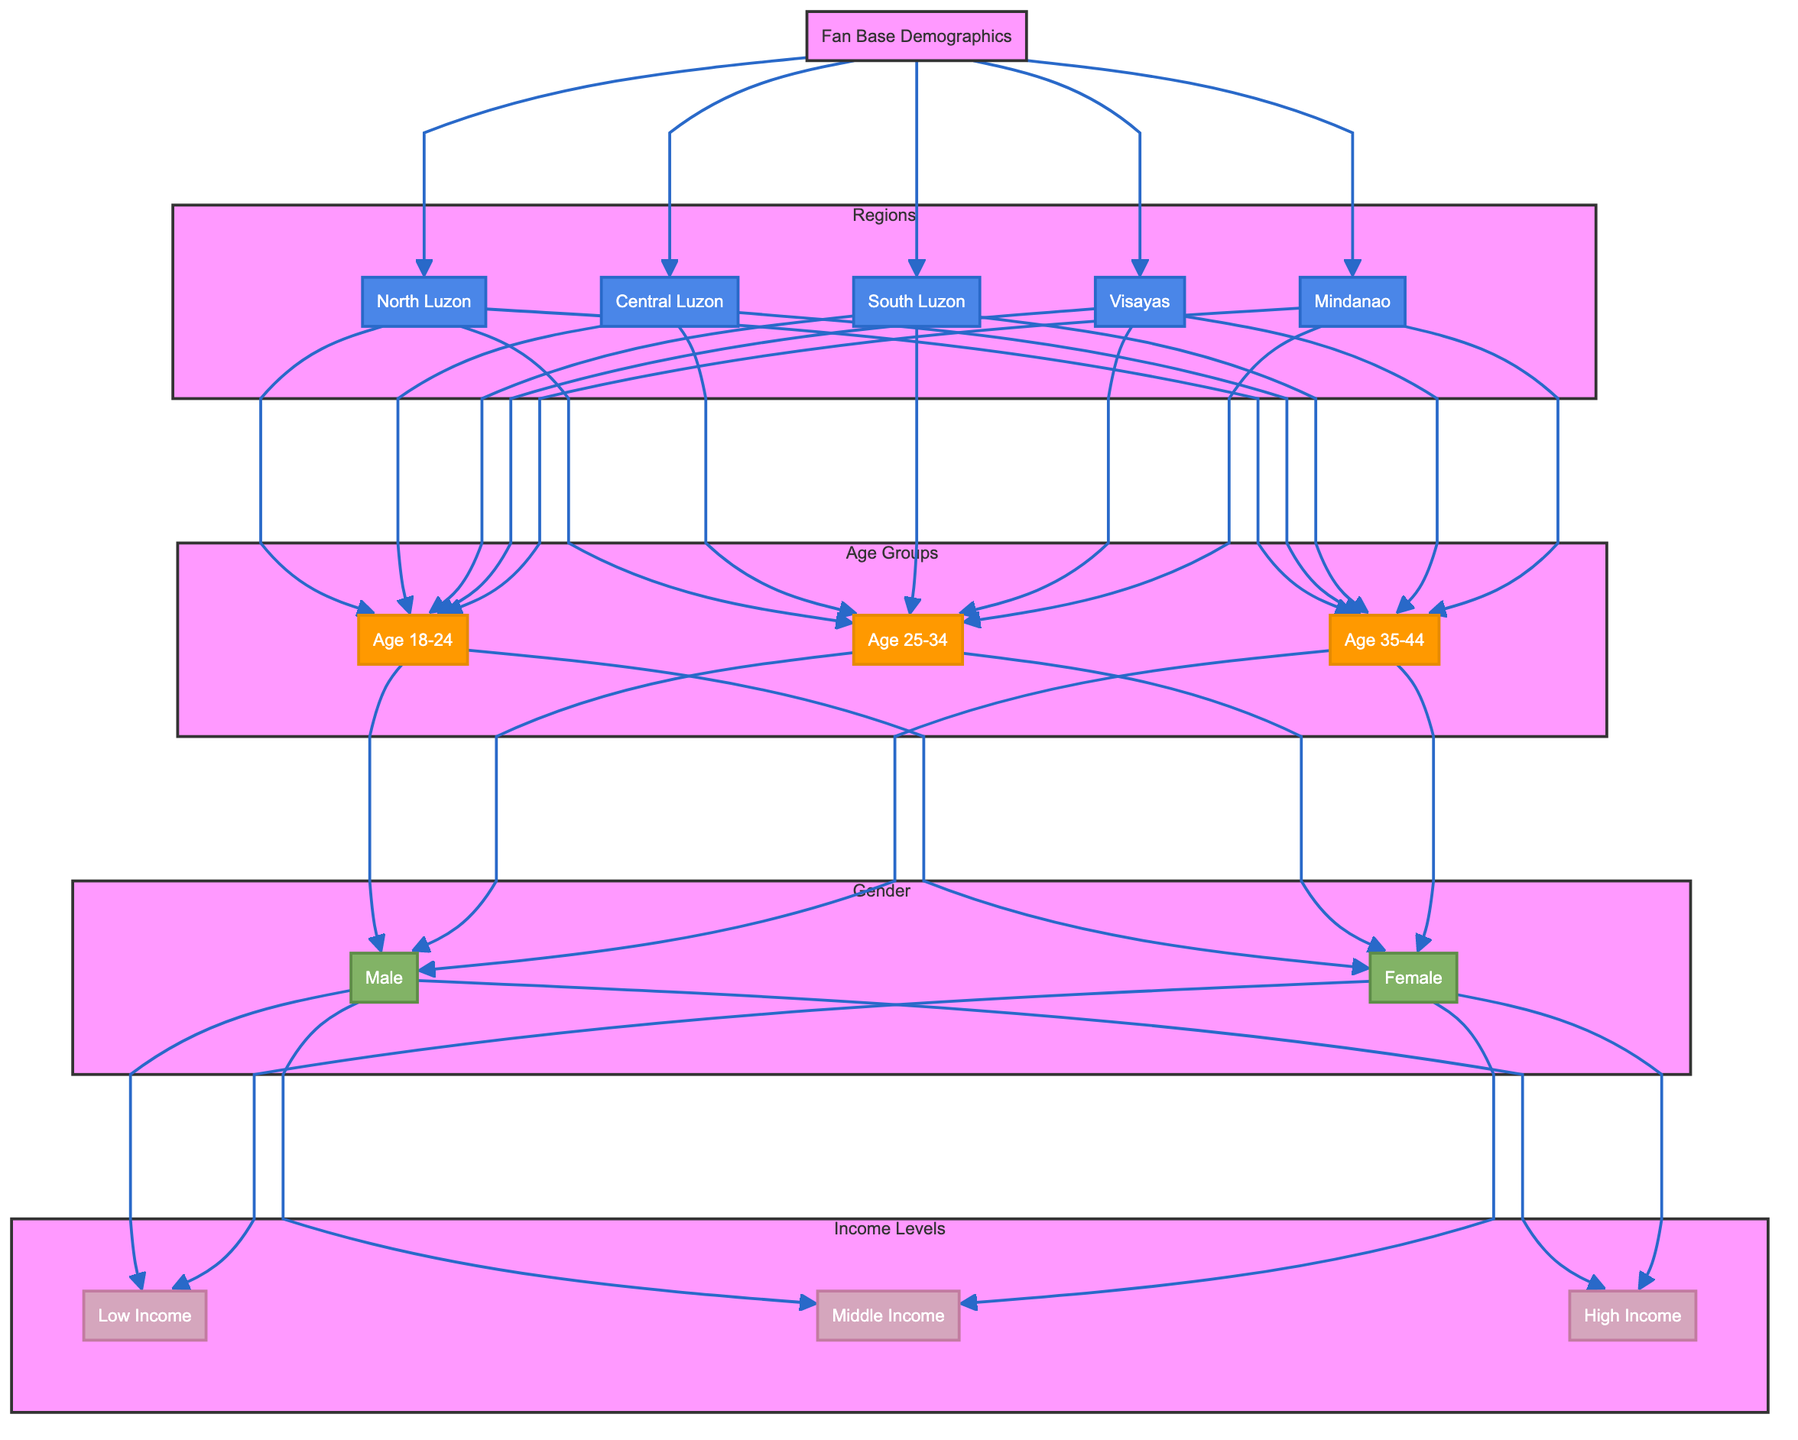What regions are represented in the fan base demographics? The diagram shows five regions: North Luzon, Central Luzon, South Luzon, Visayas, and Mindanao. These are all the sub-nodes directly connected to the root node "Fan Base Demographics."
Answer: North Luzon, Central Luzon, South Luzon, Visayas, Mindanao Which age group is represented first in the flow? The age group that appears first in the flow from the regions is "Age 18-24." This node is directly connected from all the regions as the first age group listed.
Answer: Age 18-24 How many gender categories are included in this diagram? The diagram includes two gender categories, "Male" and "Female," as indicated in the gender subgraph.
Answer: 2 Which income level is connected to the "Female" node? The "Female" node is connected to all three income levels: Low Income, Middle Income, and High Income. This is seen as branches stemming from the Female node in the diagram.
Answer: Low Income, Middle Income, High Income What is the relationship between the "Visayas" region and the "Age 25-34" group? The relationship is that the "Visayas" region has a direct connection to the "Age 25-34" group, indicating that there are fans in that region who are part of this age group.
Answer: Direct connection What is the overall flow from regions to income levels? The flow is as follows: Each region connects to the three age groups, and each age group then connects to both gender categories, which finally connect to all income levels. This demonstrates how demographics are organized from regions down to income levels.
Answer: Regions → Age Groups → Gender → Income Levels Which demographic category has the highest number of nodes in this diagram? The "Income Levels" category has three nodes: Low Income, Middle Income, and High Income. This is compared to the two nodes in the gender category and three in the age category, making it the largest single demographic category in terms of nodes.
Answer: Income Levels What color represents the age groups in the diagram? The age groups are represented in orange, as defined in the diagram's style settings where the fill color for age group elements is specified.
Answer: Orange How many different age groups are represented in total? The diagram includes three different age groups: Age 18-24, Age 25-34, and Age 35-44, as visible in the subgraph for age groups.
Answer: 3 